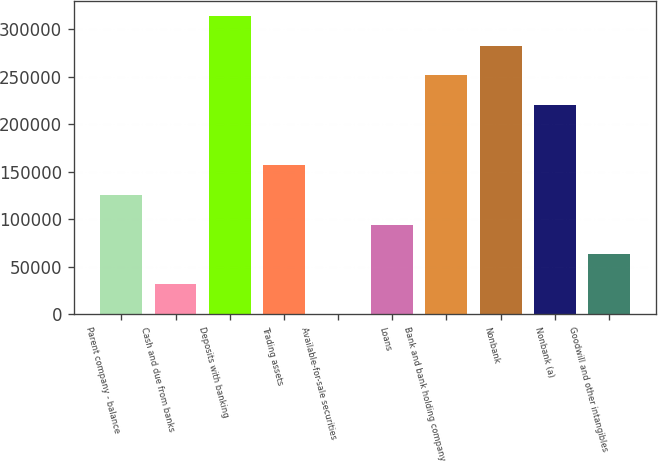Convert chart to OTSL. <chart><loc_0><loc_0><loc_500><loc_500><bar_chart><fcel>Parent company - balance<fcel>Cash and due from banks<fcel>Deposits with banking<fcel>Trading assets<fcel>Available-for-sale securities<fcel>Loans<fcel>Bank and bank holding company<fcel>Nonbank<fcel>Nonbank (a)<fcel>Goodwill and other intangibles<nl><fcel>125715<fcel>31461<fcel>314223<fcel>157133<fcel>43<fcel>94297<fcel>251387<fcel>282805<fcel>219969<fcel>62879<nl></chart> 